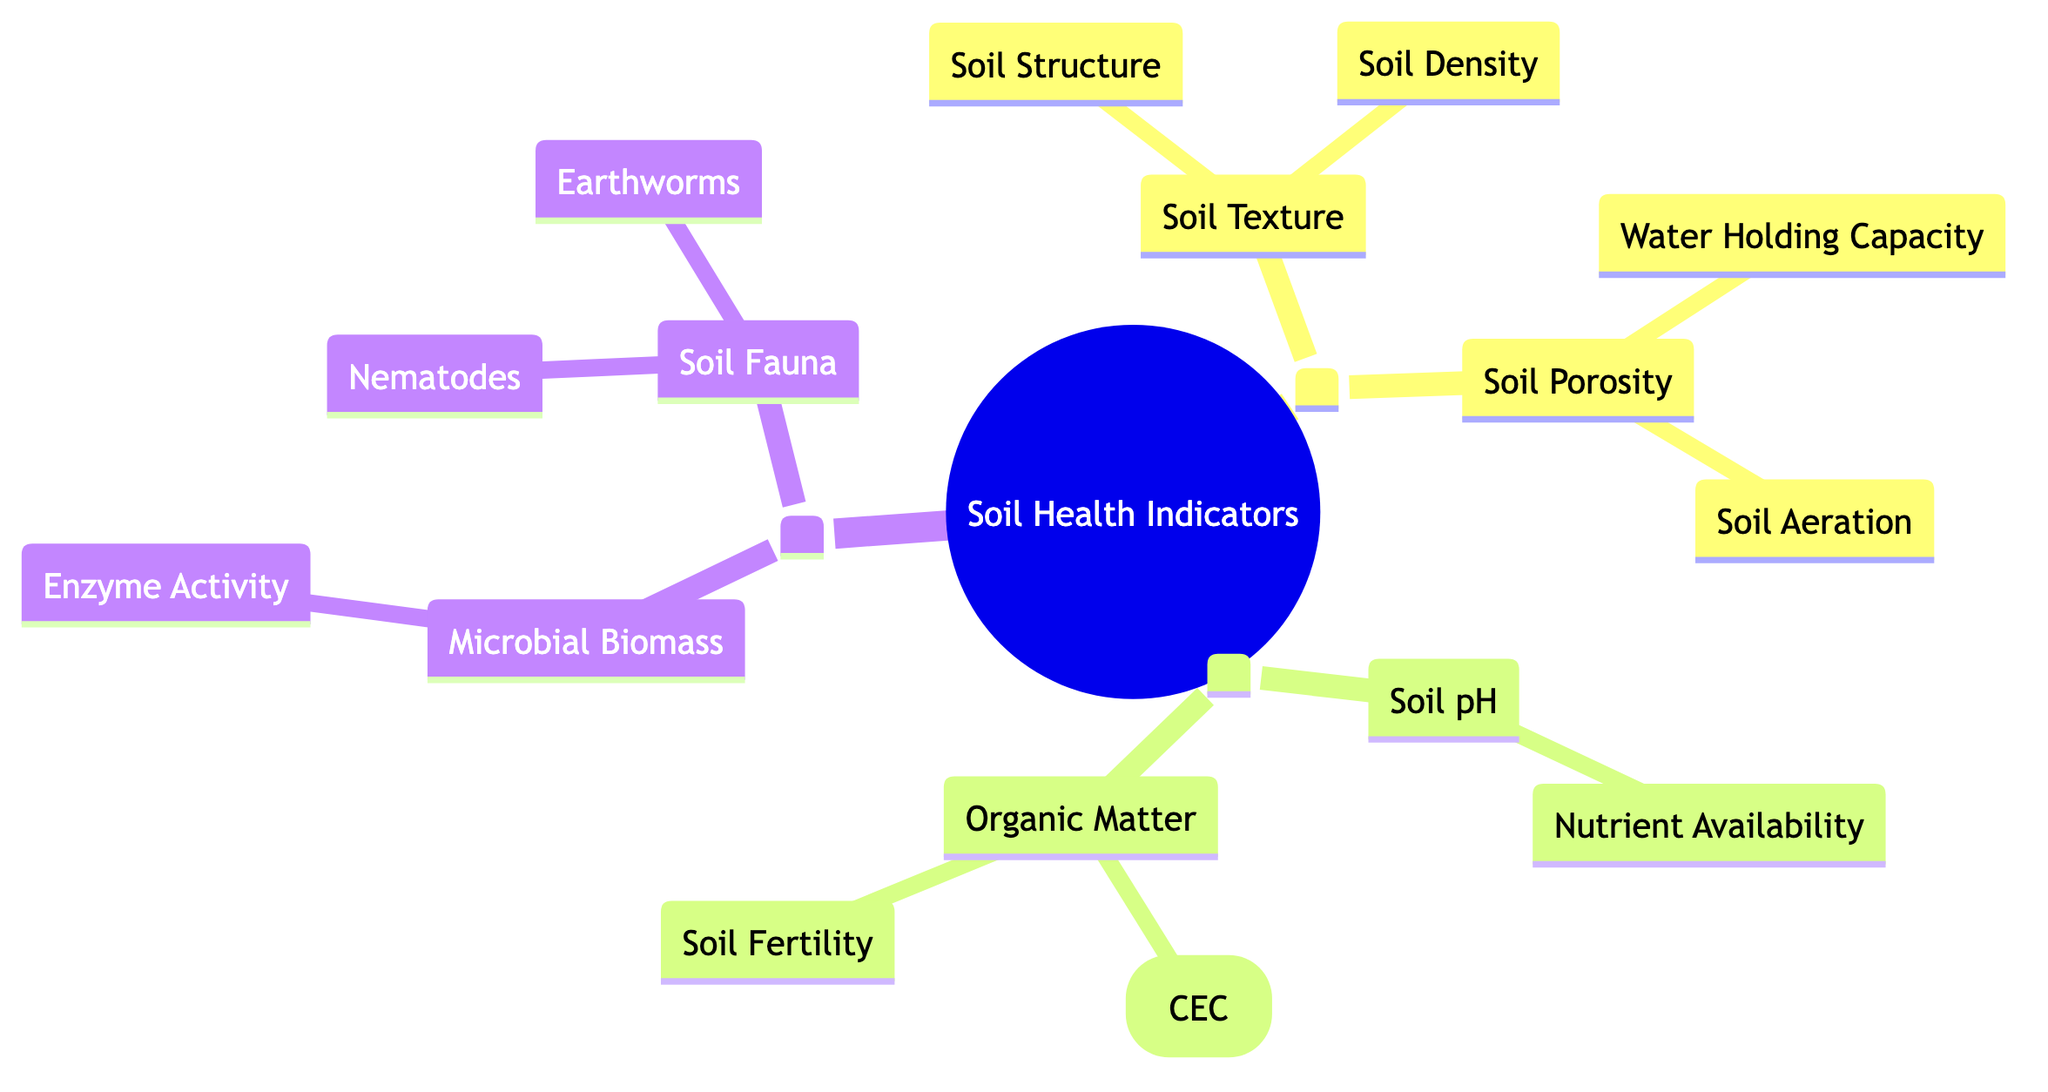What are the two main categories of soil health properties? The diagram displays three main categories, but to answer this specific question, we focus on the first two generations, which are "Soil Physical Properties" and "Soil Chemical Properties."
Answer: Soil Physical Properties, Soil Chemical Properties How many elements are listed under Soil Chemical Properties? Under "Soil Chemical Properties," there are two elements explicitly displayed: "Soil pH" and "Organic Matter." Thus, the count is 2.
Answer: 2 What is the relationship between Soil Texture and Soil Structure? "Soil Texture" is a parent node of "Soil Structure," meaning that "Soil Structure" is a child of "Soil Texture." This indicates a direct relationship where "Soil Structure" is influenced by "Soil Texture."
Answer: Parent-Child Relationship Which element has the highest number of children in the diagram? Examining the elements under each category, "Organic Matter" in the second generation has two children: "Cation Exchange Capacity (CEC)" and "Soil Fertility," while other elements have one or no children. Therefore, "Organic Matter" has the most children.
Answer: Organic Matter What is the description of Soil Fauna? The description of "Soil Fauna" is outlined directly in the diagram as "The animals living in the soil that affect its properties and processes," providing a clear understanding of what it encompasses.
Answer: The animals living in the soil that affect its properties and processes How does Soil Aeration relate to Soil Porosity? "Soil Aeration" is a child of "Soil Porosity," indicating that it is a specific characteristic or aspect influenced by the volume of pores or spaces in the soil, which is defined as "Soil Porosity." Thus, it is a more specific concept derived from the parent "Soil Porosity."
Answer: Child of Soil Porosity What is the role of Earthworms in soil health according to the diagram? The diagram describes "Earthworms" as entities that "improve soil structure, nutrient cycling, and aeration," highlighting their significant contribution to soil health.
Answer: Improve soil structure, nutrient cycling, and aeration How many biological properties are summarized in the third generation? In the third generation, there are two elements identified: "Microbial Biomass" and "Soil Fauna." Thus, the total count of biological properties represented is 2.
Answer: 2 